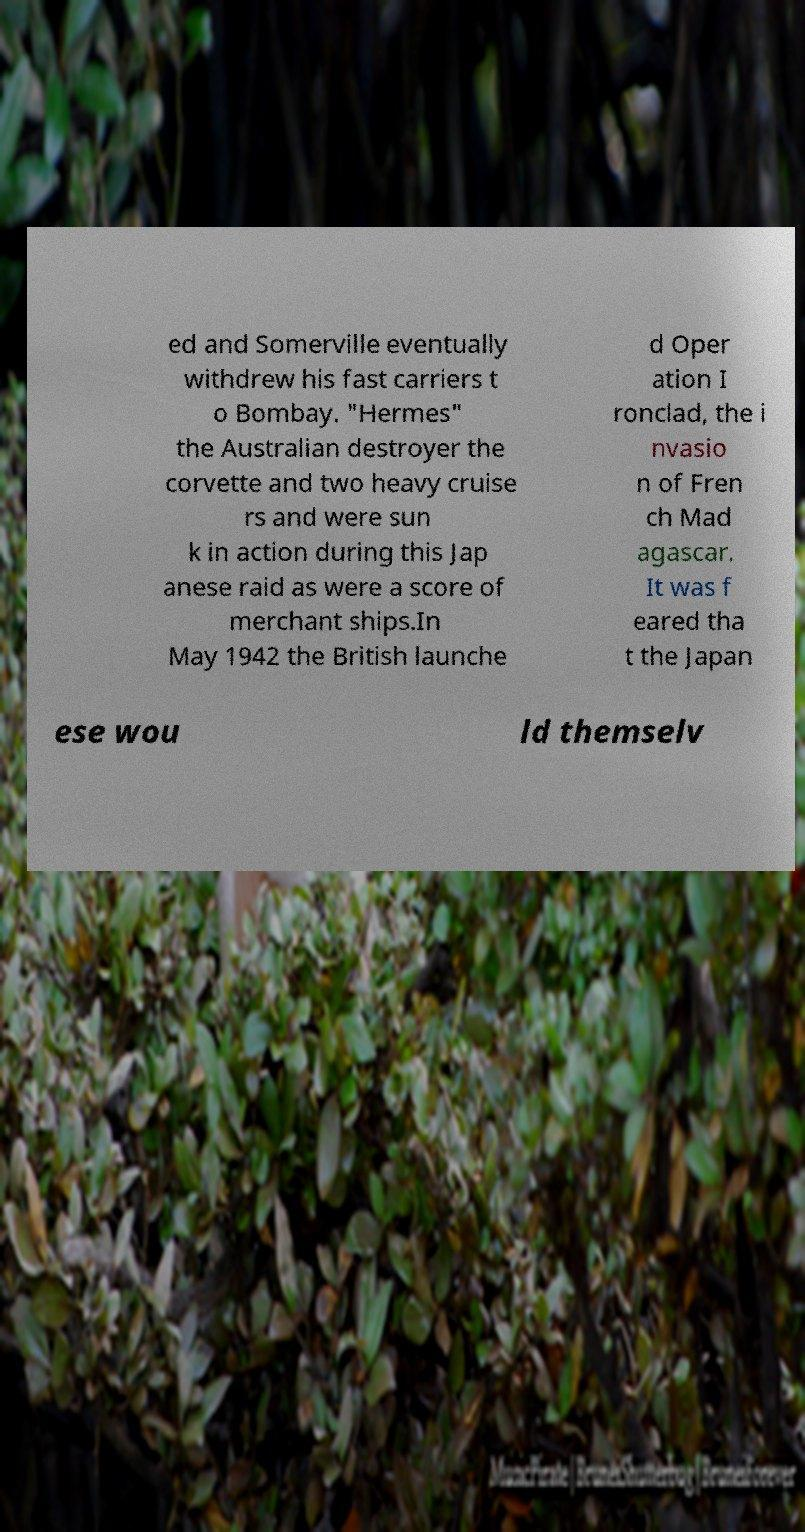Could you extract and type out the text from this image? ed and Somerville eventually withdrew his fast carriers t o Bombay. "Hermes" the Australian destroyer the corvette and two heavy cruise rs and were sun k in action during this Jap anese raid as were a score of merchant ships.In May 1942 the British launche d Oper ation I ronclad, the i nvasio n of Fren ch Mad agascar. It was f eared tha t the Japan ese wou ld themselv 